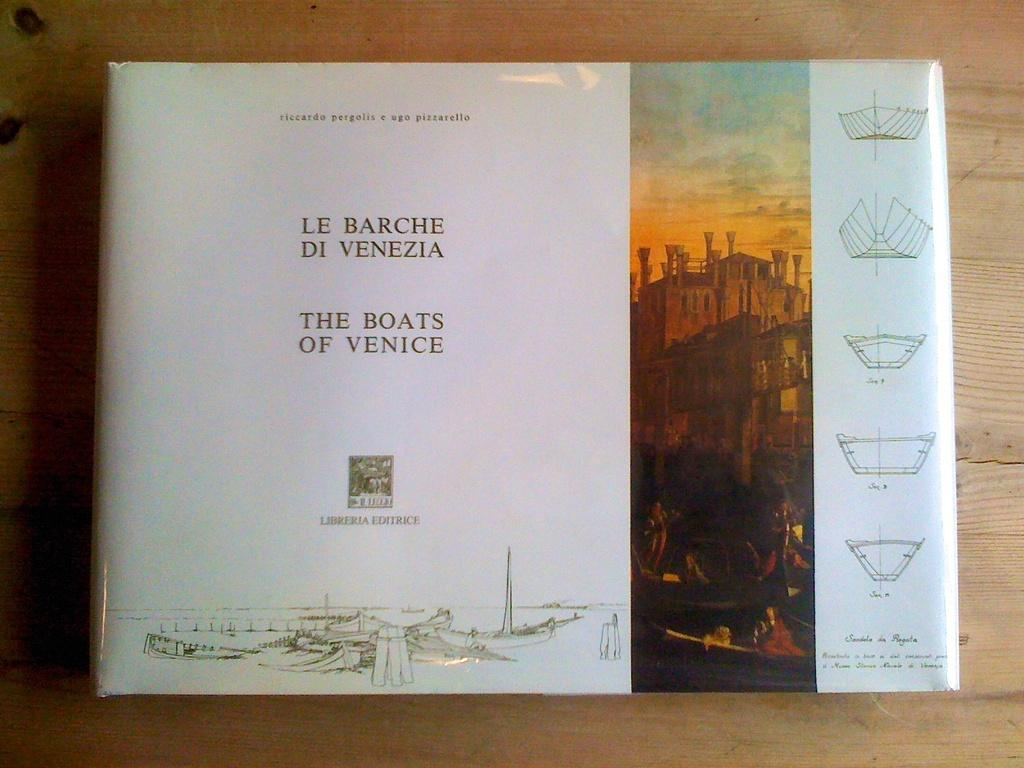What object is present in the image? There is a book in the image. Where is the book located? The book is on a wooden table. What type of cloud can be seen in the image? There is no cloud present in the image; it only features a book on a wooden table. 